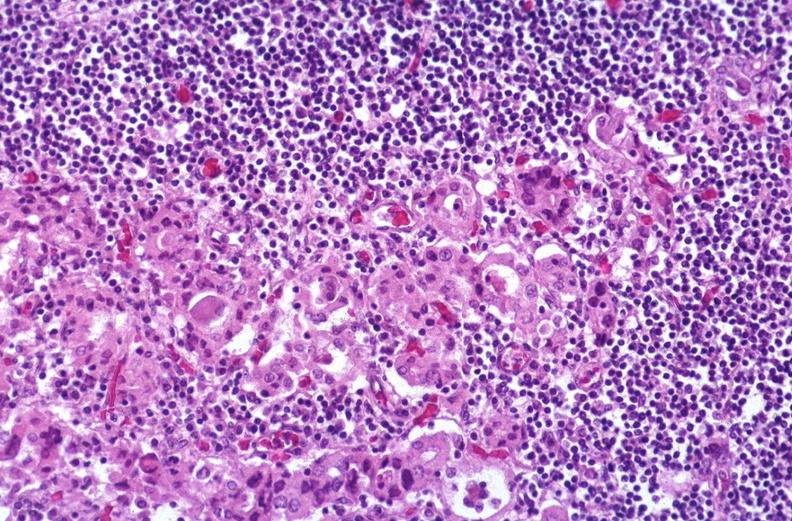what is present?
Answer the question using a single word or phrase. Endocrine 